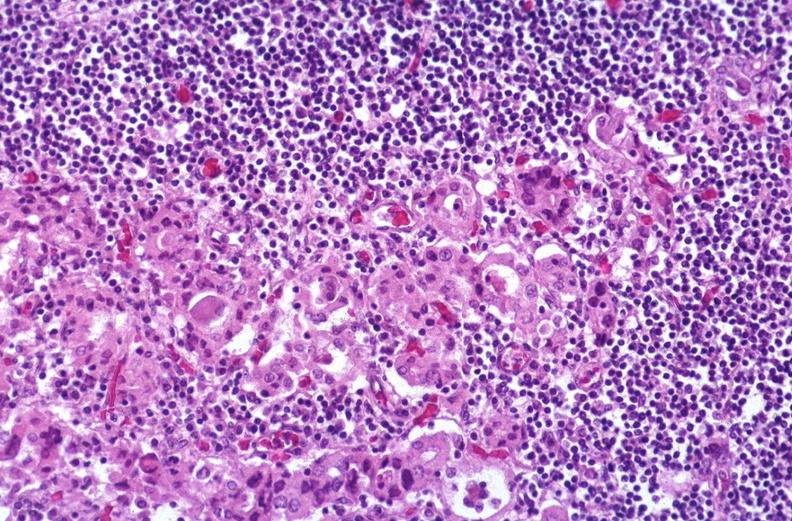what is present?
Answer the question using a single word or phrase. Endocrine 